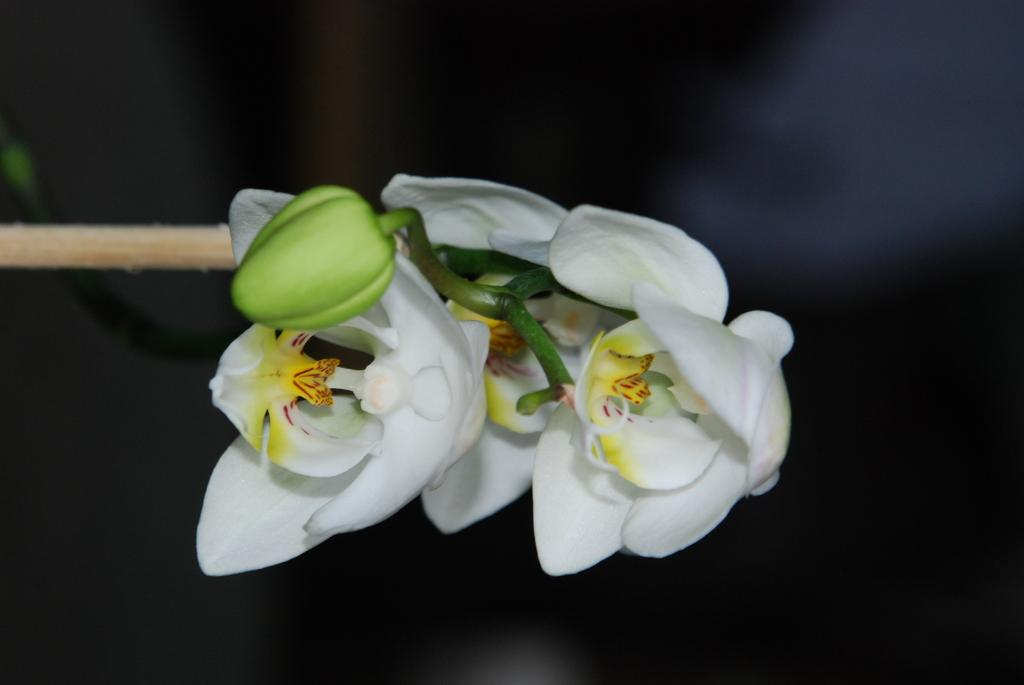What type of living organisms are present in the image? There are flowers in the image. What colors can be seen in the flowers? The flowers are in white and yellow colors. What color is the background of the image? The background of the image is black. What type of development is being discussed by the committee in the image? There is no committee or development present in the image; it features flowers with a black background. 